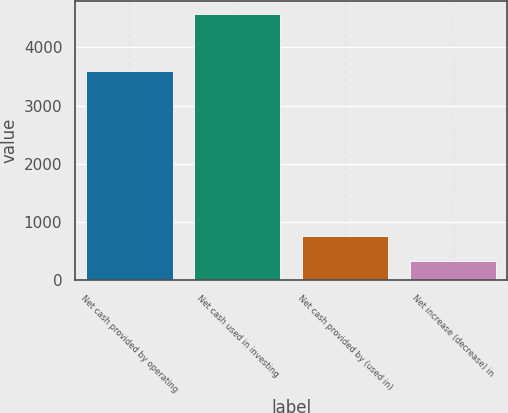<chart> <loc_0><loc_0><loc_500><loc_500><bar_chart><fcel>Net cash provided by operating<fcel>Net cash used in investing<fcel>Net cash provided by (used in)<fcel>Net increase (decrease) in<nl><fcel>3593<fcel>4578<fcel>754.8<fcel>330<nl></chart> 